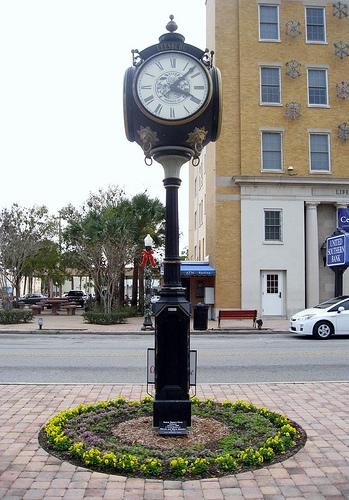Question: why is it light outside?
Choices:
A. Stadium lights.
B. A full moon.
C. Daytime.
D. A fire.
Answer with the letter. Answer: C Question: what color is the car in front of the bank?
Choices:
A. Blue.
B. White.
C. Black.
D. Red.
Answer with the letter. Answer: B Question: when was this photo taken?
Choices:
A. 3:00.
B. 4:45.
C. 1:18.
D. 4:07.
Answer with the letter. Answer: D Question: where are the bell decorations?
Choices:
A. On a church.
B. On the bank building.
C. On a school.
D. On a library.
Answer with the letter. Answer: B Question: what holiday was this photo taken around?
Choices:
A. Halloween.
B. Thanksgiving.
C. Christmas.
D. Independence Day.
Answer with the letter. Answer: C Question: who is standing next to the clock?
Choices:
A. A man.
B. A woman.
C. Children.
D. No one.
Answer with the letter. Answer: D 